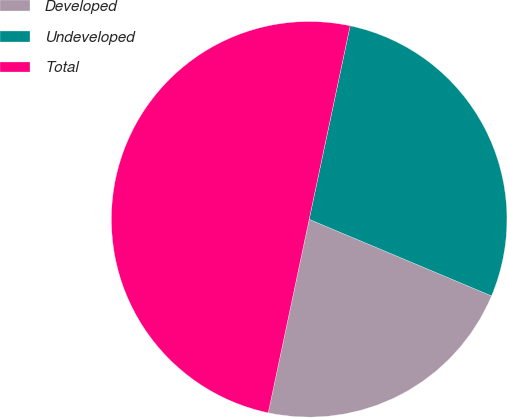Convert chart to OTSL. <chart><loc_0><loc_0><loc_500><loc_500><pie_chart><fcel>Developed<fcel>Undeveloped<fcel>Total<nl><fcel>21.99%<fcel>28.01%<fcel>50.0%<nl></chart> 